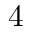<formula> <loc_0><loc_0><loc_500><loc_500>4</formula> 